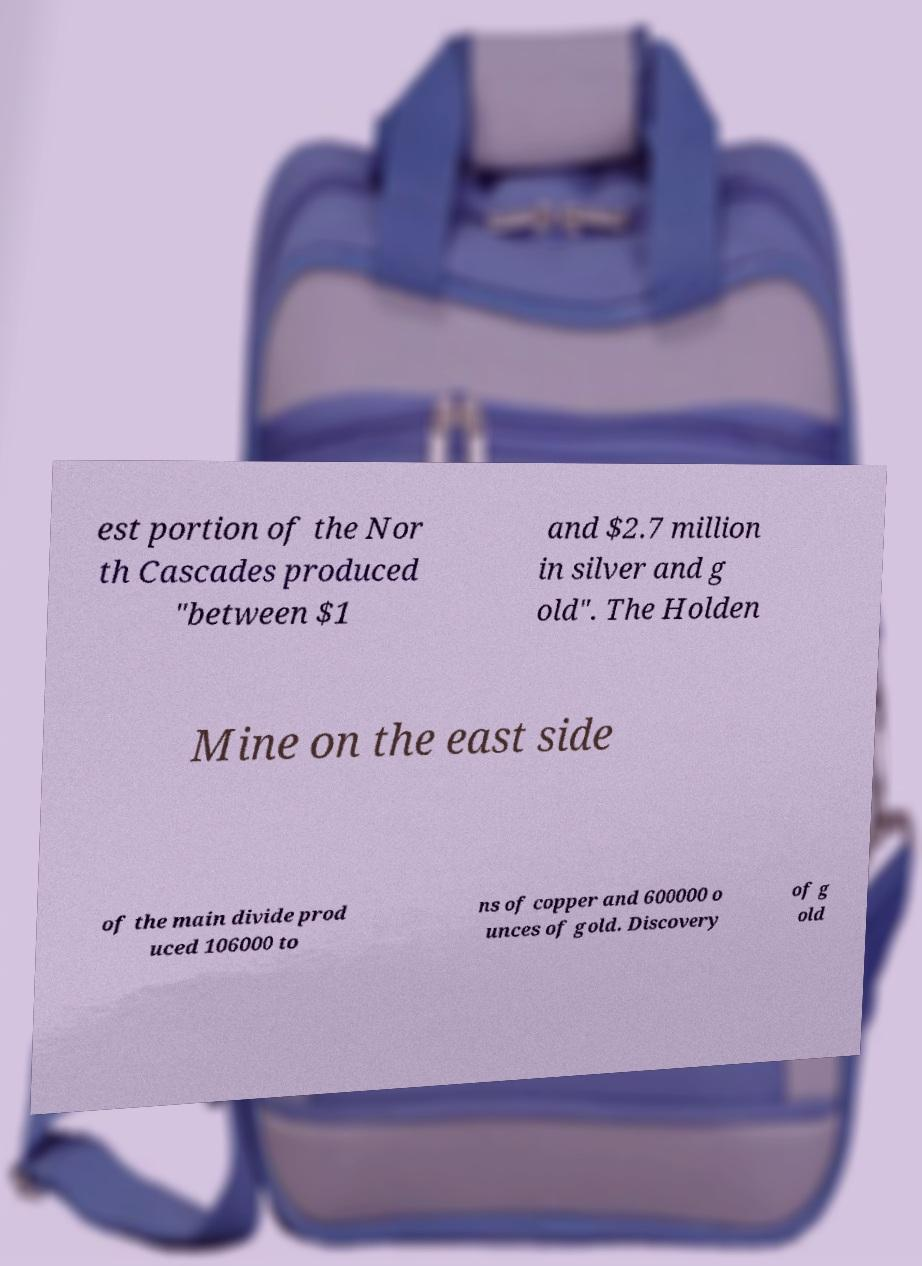What messages or text are displayed in this image? I need them in a readable, typed format. est portion of the Nor th Cascades produced "between $1 and $2.7 million in silver and g old". The Holden Mine on the east side of the main divide prod uced 106000 to ns of copper and 600000 o unces of gold. Discovery of g old 